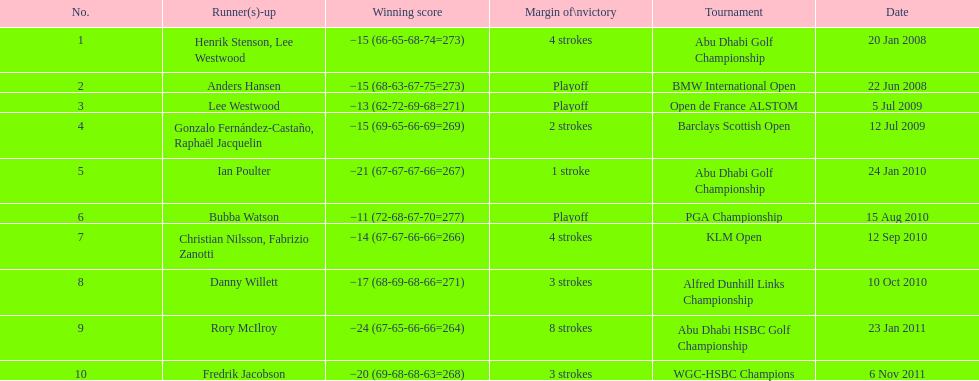How long separated the playoff victory at bmw international open and the 4 stroke victory at the klm open? 2 years. 